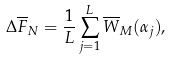Convert formula to latex. <formula><loc_0><loc_0><loc_500><loc_500>\Delta \overline { F } _ { N } = \frac { 1 } { L } \sum _ { j = 1 } ^ { L } \overline { W } _ { M } ( \alpha _ { j } ) ,</formula> 